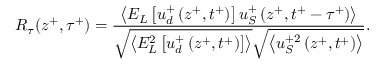<formula> <loc_0><loc_0><loc_500><loc_500>R _ { \tau } ( z ^ { + } , \tau ^ { + } ) = \frac { \left < E _ { L } \left [ u _ { d } ^ { + } \left ( z ^ { + } , t ^ { + } \right ) \right ] u _ { S } ^ { + } \left ( z ^ { + } , t ^ { + } - \tau ^ { + } \right ) \right > } { \sqrt { \left < E _ { L } ^ { 2 } \left [ u _ { d } ^ { + } \left ( z ^ { + } , t ^ { + } \right ) \right ] \right > } \sqrt { \left < u _ { S } ^ { + 2 } \left ( z ^ { + } , t ^ { + } \right ) \right > } } .</formula> 